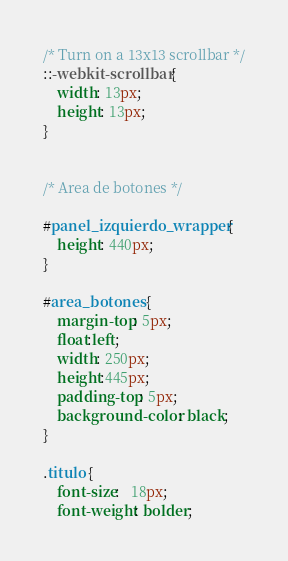<code> <loc_0><loc_0><loc_500><loc_500><_CSS_>/* Turn on a 13x13 scrollbar */
::-webkit-scrollbar {
    width: 13px;
    height: 13px;
}


/* Area de botones */

#panel_izquierdo_wrapper {
    height: 440px;
}

#area_botones {
    margin-top: 5px;
    float:left;
    width: 250px;
    height:445px;
    padding-top: 5px;
    background-color: black;
}

.titulo {
    font-size:   18px;
    font-weight: bolder;</code> 